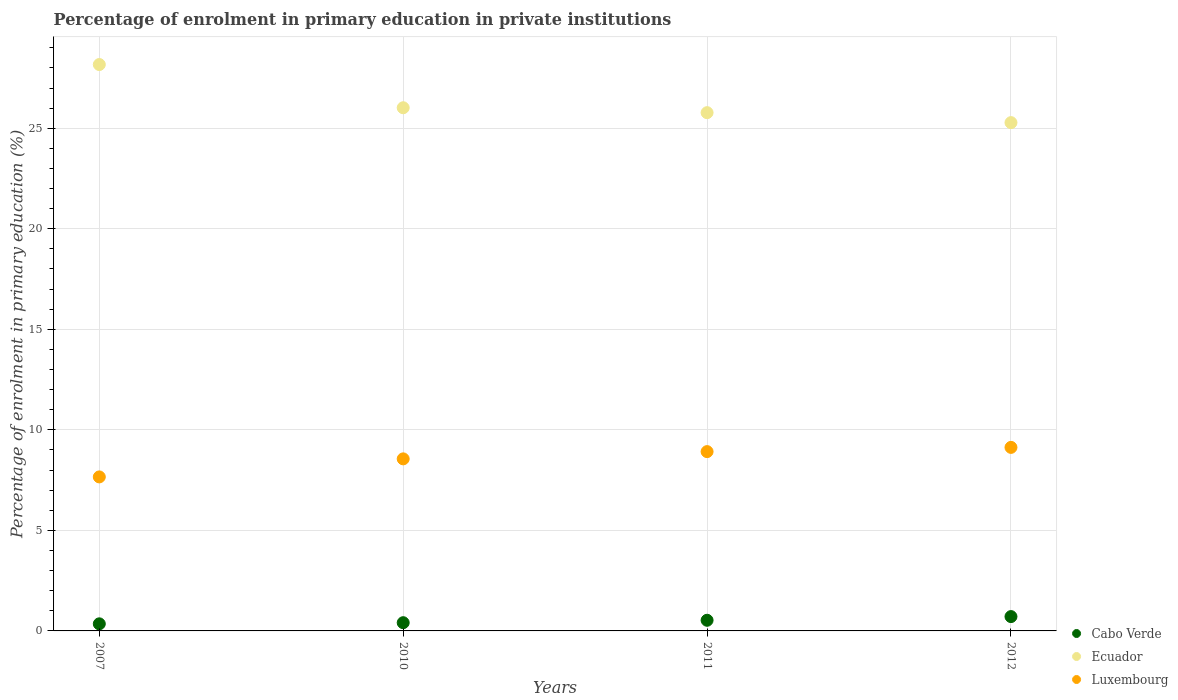How many different coloured dotlines are there?
Keep it short and to the point. 3. Is the number of dotlines equal to the number of legend labels?
Ensure brevity in your answer.  Yes. What is the percentage of enrolment in primary education in Luxembourg in 2011?
Your response must be concise. 8.92. Across all years, what is the maximum percentage of enrolment in primary education in Luxembourg?
Give a very brief answer. 9.13. Across all years, what is the minimum percentage of enrolment in primary education in Ecuador?
Keep it short and to the point. 25.28. What is the total percentage of enrolment in primary education in Luxembourg in the graph?
Ensure brevity in your answer.  34.26. What is the difference between the percentage of enrolment in primary education in Luxembourg in 2010 and that in 2012?
Provide a succinct answer. -0.57. What is the difference between the percentage of enrolment in primary education in Luxembourg in 2011 and the percentage of enrolment in primary education in Ecuador in 2012?
Ensure brevity in your answer.  -16.36. What is the average percentage of enrolment in primary education in Ecuador per year?
Offer a very short reply. 26.31. In the year 2011, what is the difference between the percentage of enrolment in primary education in Luxembourg and percentage of enrolment in primary education in Cabo Verde?
Provide a short and direct response. 8.39. In how many years, is the percentage of enrolment in primary education in Cabo Verde greater than 19 %?
Provide a succinct answer. 0. What is the ratio of the percentage of enrolment in primary education in Luxembourg in 2007 to that in 2011?
Ensure brevity in your answer.  0.86. Is the difference between the percentage of enrolment in primary education in Luxembourg in 2007 and 2012 greater than the difference between the percentage of enrolment in primary education in Cabo Verde in 2007 and 2012?
Offer a terse response. No. What is the difference between the highest and the second highest percentage of enrolment in primary education in Ecuador?
Your response must be concise. 2.15. What is the difference between the highest and the lowest percentage of enrolment in primary education in Luxembourg?
Provide a short and direct response. 1.47. In how many years, is the percentage of enrolment in primary education in Luxembourg greater than the average percentage of enrolment in primary education in Luxembourg taken over all years?
Provide a short and direct response. 2. Is the sum of the percentage of enrolment in primary education in Ecuador in 2007 and 2010 greater than the maximum percentage of enrolment in primary education in Cabo Verde across all years?
Keep it short and to the point. Yes. Is it the case that in every year, the sum of the percentage of enrolment in primary education in Luxembourg and percentage of enrolment in primary education in Cabo Verde  is greater than the percentage of enrolment in primary education in Ecuador?
Your answer should be very brief. No. Does the percentage of enrolment in primary education in Luxembourg monotonically increase over the years?
Offer a very short reply. Yes. Is the percentage of enrolment in primary education in Cabo Verde strictly greater than the percentage of enrolment in primary education in Ecuador over the years?
Your answer should be compact. No. Are the values on the major ticks of Y-axis written in scientific E-notation?
Give a very brief answer. No. Does the graph contain any zero values?
Provide a succinct answer. No. Does the graph contain grids?
Your response must be concise. Yes. What is the title of the graph?
Ensure brevity in your answer.  Percentage of enrolment in primary education in private institutions. Does "Tanzania" appear as one of the legend labels in the graph?
Offer a very short reply. No. What is the label or title of the X-axis?
Your response must be concise. Years. What is the label or title of the Y-axis?
Your answer should be compact. Percentage of enrolment in primary education (%). What is the Percentage of enrolment in primary education (%) in Cabo Verde in 2007?
Provide a succinct answer. 0.35. What is the Percentage of enrolment in primary education (%) in Ecuador in 2007?
Make the answer very short. 28.17. What is the Percentage of enrolment in primary education (%) of Luxembourg in 2007?
Keep it short and to the point. 7.66. What is the Percentage of enrolment in primary education (%) of Cabo Verde in 2010?
Provide a succinct answer. 0.41. What is the Percentage of enrolment in primary education (%) of Ecuador in 2010?
Offer a very short reply. 26.02. What is the Percentage of enrolment in primary education (%) of Luxembourg in 2010?
Offer a terse response. 8.56. What is the Percentage of enrolment in primary education (%) in Cabo Verde in 2011?
Ensure brevity in your answer.  0.53. What is the Percentage of enrolment in primary education (%) of Ecuador in 2011?
Provide a short and direct response. 25.77. What is the Percentage of enrolment in primary education (%) in Luxembourg in 2011?
Provide a short and direct response. 8.92. What is the Percentage of enrolment in primary education (%) in Cabo Verde in 2012?
Ensure brevity in your answer.  0.71. What is the Percentage of enrolment in primary education (%) in Ecuador in 2012?
Your answer should be very brief. 25.28. What is the Percentage of enrolment in primary education (%) of Luxembourg in 2012?
Your answer should be very brief. 9.13. Across all years, what is the maximum Percentage of enrolment in primary education (%) in Cabo Verde?
Ensure brevity in your answer.  0.71. Across all years, what is the maximum Percentage of enrolment in primary education (%) in Ecuador?
Provide a succinct answer. 28.17. Across all years, what is the maximum Percentage of enrolment in primary education (%) of Luxembourg?
Make the answer very short. 9.13. Across all years, what is the minimum Percentage of enrolment in primary education (%) of Cabo Verde?
Your answer should be very brief. 0.35. Across all years, what is the minimum Percentage of enrolment in primary education (%) of Ecuador?
Provide a short and direct response. 25.28. Across all years, what is the minimum Percentage of enrolment in primary education (%) of Luxembourg?
Your response must be concise. 7.66. What is the total Percentage of enrolment in primary education (%) in Cabo Verde in the graph?
Make the answer very short. 2. What is the total Percentage of enrolment in primary education (%) of Ecuador in the graph?
Provide a short and direct response. 105.24. What is the total Percentage of enrolment in primary education (%) in Luxembourg in the graph?
Your answer should be compact. 34.26. What is the difference between the Percentage of enrolment in primary education (%) of Cabo Verde in 2007 and that in 2010?
Your answer should be compact. -0.06. What is the difference between the Percentage of enrolment in primary education (%) in Ecuador in 2007 and that in 2010?
Provide a succinct answer. 2.15. What is the difference between the Percentage of enrolment in primary education (%) in Luxembourg in 2007 and that in 2010?
Your answer should be very brief. -0.9. What is the difference between the Percentage of enrolment in primary education (%) of Cabo Verde in 2007 and that in 2011?
Your response must be concise. -0.18. What is the difference between the Percentage of enrolment in primary education (%) in Ecuador in 2007 and that in 2011?
Provide a succinct answer. 2.39. What is the difference between the Percentage of enrolment in primary education (%) of Luxembourg in 2007 and that in 2011?
Offer a very short reply. -1.26. What is the difference between the Percentage of enrolment in primary education (%) of Cabo Verde in 2007 and that in 2012?
Give a very brief answer. -0.36. What is the difference between the Percentage of enrolment in primary education (%) in Ecuador in 2007 and that in 2012?
Offer a very short reply. 2.89. What is the difference between the Percentage of enrolment in primary education (%) in Luxembourg in 2007 and that in 2012?
Ensure brevity in your answer.  -1.47. What is the difference between the Percentage of enrolment in primary education (%) of Cabo Verde in 2010 and that in 2011?
Offer a terse response. -0.12. What is the difference between the Percentage of enrolment in primary education (%) in Ecuador in 2010 and that in 2011?
Offer a very short reply. 0.24. What is the difference between the Percentage of enrolment in primary education (%) in Luxembourg in 2010 and that in 2011?
Offer a terse response. -0.36. What is the difference between the Percentage of enrolment in primary education (%) of Cabo Verde in 2010 and that in 2012?
Your response must be concise. -0.3. What is the difference between the Percentage of enrolment in primary education (%) in Ecuador in 2010 and that in 2012?
Your answer should be compact. 0.74. What is the difference between the Percentage of enrolment in primary education (%) in Luxembourg in 2010 and that in 2012?
Your response must be concise. -0.57. What is the difference between the Percentage of enrolment in primary education (%) of Cabo Verde in 2011 and that in 2012?
Make the answer very short. -0.18. What is the difference between the Percentage of enrolment in primary education (%) of Ecuador in 2011 and that in 2012?
Your answer should be very brief. 0.5. What is the difference between the Percentage of enrolment in primary education (%) in Luxembourg in 2011 and that in 2012?
Offer a very short reply. -0.21. What is the difference between the Percentage of enrolment in primary education (%) in Cabo Verde in 2007 and the Percentage of enrolment in primary education (%) in Ecuador in 2010?
Offer a very short reply. -25.67. What is the difference between the Percentage of enrolment in primary education (%) in Cabo Verde in 2007 and the Percentage of enrolment in primary education (%) in Luxembourg in 2010?
Your answer should be very brief. -8.2. What is the difference between the Percentage of enrolment in primary education (%) of Ecuador in 2007 and the Percentage of enrolment in primary education (%) of Luxembourg in 2010?
Offer a very short reply. 19.61. What is the difference between the Percentage of enrolment in primary education (%) in Cabo Verde in 2007 and the Percentage of enrolment in primary education (%) in Ecuador in 2011?
Keep it short and to the point. -25.42. What is the difference between the Percentage of enrolment in primary education (%) of Cabo Verde in 2007 and the Percentage of enrolment in primary education (%) of Luxembourg in 2011?
Keep it short and to the point. -8.56. What is the difference between the Percentage of enrolment in primary education (%) in Ecuador in 2007 and the Percentage of enrolment in primary education (%) in Luxembourg in 2011?
Provide a succinct answer. 19.25. What is the difference between the Percentage of enrolment in primary education (%) of Cabo Verde in 2007 and the Percentage of enrolment in primary education (%) of Ecuador in 2012?
Offer a terse response. -24.93. What is the difference between the Percentage of enrolment in primary education (%) in Cabo Verde in 2007 and the Percentage of enrolment in primary education (%) in Luxembourg in 2012?
Give a very brief answer. -8.78. What is the difference between the Percentage of enrolment in primary education (%) in Ecuador in 2007 and the Percentage of enrolment in primary education (%) in Luxembourg in 2012?
Your response must be concise. 19.04. What is the difference between the Percentage of enrolment in primary education (%) in Cabo Verde in 2010 and the Percentage of enrolment in primary education (%) in Ecuador in 2011?
Provide a short and direct response. -25.37. What is the difference between the Percentage of enrolment in primary education (%) in Cabo Verde in 2010 and the Percentage of enrolment in primary education (%) in Luxembourg in 2011?
Provide a succinct answer. -8.51. What is the difference between the Percentage of enrolment in primary education (%) in Ecuador in 2010 and the Percentage of enrolment in primary education (%) in Luxembourg in 2011?
Provide a short and direct response. 17.1. What is the difference between the Percentage of enrolment in primary education (%) in Cabo Verde in 2010 and the Percentage of enrolment in primary education (%) in Ecuador in 2012?
Give a very brief answer. -24.87. What is the difference between the Percentage of enrolment in primary education (%) in Cabo Verde in 2010 and the Percentage of enrolment in primary education (%) in Luxembourg in 2012?
Keep it short and to the point. -8.72. What is the difference between the Percentage of enrolment in primary education (%) in Ecuador in 2010 and the Percentage of enrolment in primary education (%) in Luxembourg in 2012?
Offer a terse response. 16.89. What is the difference between the Percentage of enrolment in primary education (%) in Cabo Verde in 2011 and the Percentage of enrolment in primary education (%) in Ecuador in 2012?
Ensure brevity in your answer.  -24.75. What is the difference between the Percentage of enrolment in primary education (%) of Cabo Verde in 2011 and the Percentage of enrolment in primary education (%) of Luxembourg in 2012?
Give a very brief answer. -8.6. What is the difference between the Percentage of enrolment in primary education (%) in Ecuador in 2011 and the Percentage of enrolment in primary education (%) in Luxembourg in 2012?
Offer a terse response. 16.65. What is the average Percentage of enrolment in primary education (%) in Cabo Verde per year?
Make the answer very short. 0.5. What is the average Percentage of enrolment in primary education (%) in Ecuador per year?
Provide a succinct answer. 26.31. What is the average Percentage of enrolment in primary education (%) of Luxembourg per year?
Keep it short and to the point. 8.57. In the year 2007, what is the difference between the Percentage of enrolment in primary education (%) of Cabo Verde and Percentage of enrolment in primary education (%) of Ecuador?
Give a very brief answer. -27.82. In the year 2007, what is the difference between the Percentage of enrolment in primary education (%) of Cabo Verde and Percentage of enrolment in primary education (%) of Luxembourg?
Your answer should be very brief. -7.31. In the year 2007, what is the difference between the Percentage of enrolment in primary education (%) of Ecuador and Percentage of enrolment in primary education (%) of Luxembourg?
Offer a very short reply. 20.51. In the year 2010, what is the difference between the Percentage of enrolment in primary education (%) in Cabo Verde and Percentage of enrolment in primary education (%) in Ecuador?
Offer a very short reply. -25.61. In the year 2010, what is the difference between the Percentage of enrolment in primary education (%) of Cabo Verde and Percentage of enrolment in primary education (%) of Luxembourg?
Keep it short and to the point. -8.15. In the year 2010, what is the difference between the Percentage of enrolment in primary education (%) of Ecuador and Percentage of enrolment in primary education (%) of Luxembourg?
Provide a short and direct response. 17.46. In the year 2011, what is the difference between the Percentage of enrolment in primary education (%) in Cabo Verde and Percentage of enrolment in primary education (%) in Ecuador?
Your answer should be very brief. -25.25. In the year 2011, what is the difference between the Percentage of enrolment in primary education (%) of Cabo Verde and Percentage of enrolment in primary education (%) of Luxembourg?
Your answer should be very brief. -8.39. In the year 2011, what is the difference between the Percentage of enrolment in primary education (%) of Ecuador and Percentage of enrolment in primary education (%) of Luxembourg?
Your response must be concise. 16.86. In the year 2012, what is the difference between the Percentage of enrolment in primary education (%) in Cabo Verde and Percentage of enrolment in primary education (%) in Ecuador?
Your answer should be very brief. -24.57. In the year 2012, what is the difference between the Percentage of enrolment in primary education (%) in Cabo Verde and Percentage of enrolment in primary education (%) in Luxembourg?
Your response must be concise. -8.42. In the year 2012, what is the difference between the Percentage of enrolment in primary education (%) in Ecuador and Percentage of enrolment in primary education (%) in Luxembourg?
Ensure brevity in your answer.  16.15. What is the ratio of the Percentage of enrolment in primary education (%) of Cabo Verde in 2007 to that in 2010?
Your response must be concise. 0.86. What is the ratio of the Percentage of enrolment in primary education (%) of Ecuador in 2007 to that in 2010?
Your response must be concise. 1.08. What is the ratio of the Percentage of enrolment in primary education (%) in Luxembourg in 2007 to that in 2010?
Keep it short and to the point. 0.9. What is the ratio of the Percentage of enrolment in primary education (%) in Cabo Verde in 2007 to that in 2011?
Provide a succinct answer. 0.67. What is the ratio of the Percentage of enrolment in primary education (%) in Ecuador in 2007 to that in 2011?
Provide a succinct answer. 1.09. What is the ratio of the Percentage of enrolment in primary education (%) in Luxembourg in 2007 to that in 2011?
Provide a succinct answer. 0.86. What is the ratio of the Percentage of enrolment in primary education (%) of Cabo Verde in 2007 to that in 2012?
Your answer should be compact. 0.49. What is the ratio of the Percentage of enrolment in primary education (%) of Ecuador in 2007 to that in 2012?
Provide a succinct answer. 1.11. What is the ratio of the Percentage of enrolment in primary education (%) in Luxembourg in 2007 to that in 2012?
Offer a terse response. 0.84. What is the ratio of the Percentage of enrolment in primary education (%) in Cabo Verde in 2010 to that in 2011?
Offer a terse response. 0.77. What is the ratio of the Percentage of enrolment in primary education (%) in Ecuador in 2010 to that in 2011?
Provide a succinct answer. 1.01. What is the ratio of the Percentage of enrolment in primary education (%) in Luxembourg in 2010 to that in 2011?
Provide a succinct answer. 0.96. What is the ratio of the Percentage of enrolment in primary education (%) of Cabo Verde in 2010 to that in 2012?
Your response must be concise. 0.57. What is the ratio of the Percentage of enrolment in primary education (%) of Ecuador in 2010 to that in 2012?
Make the answer very short. 1.03. What is the ratio of the Percentage of enrolment in primary education (%) in Cabo Verde in 2011 to that in 2012?
Offer a very short reply. 0.74. What is the ratio of the Percentage of enrolment in primary education (%) of Ecuador in 2011 to that in 2012?
Provide a short and direct response. 1.02. What is the difference between the highest and the second highest Percentage of enrolment in primary education (%) in Cabo Verde?
Ensure brevity in your answer.  0.18. What is the difference between the highest and the second highest Percentage of enrolment in primary education (%) in Ecuador?
Provide a short and direct response. 2.15. What is the difference between the highest and the second highest Percentage of enrolment in primary education (%) in Luxembourg?
Your response must be concise. 0.21. What is the difference between the highest and the lowest Percentage of enrolment in primary education (%) of Cabo Verde?
Your answer should be very brief. 0.36. What is the difference between the highest and the lowest Percentage of enrolment in primary education (%) of Ecuador?
Offer a terse response. 2.89. What is the difference between the highest and the lowest Percentage of enrolment in primary education (%) in Luxembourg?
Provide a succinct answer. 1.47. 